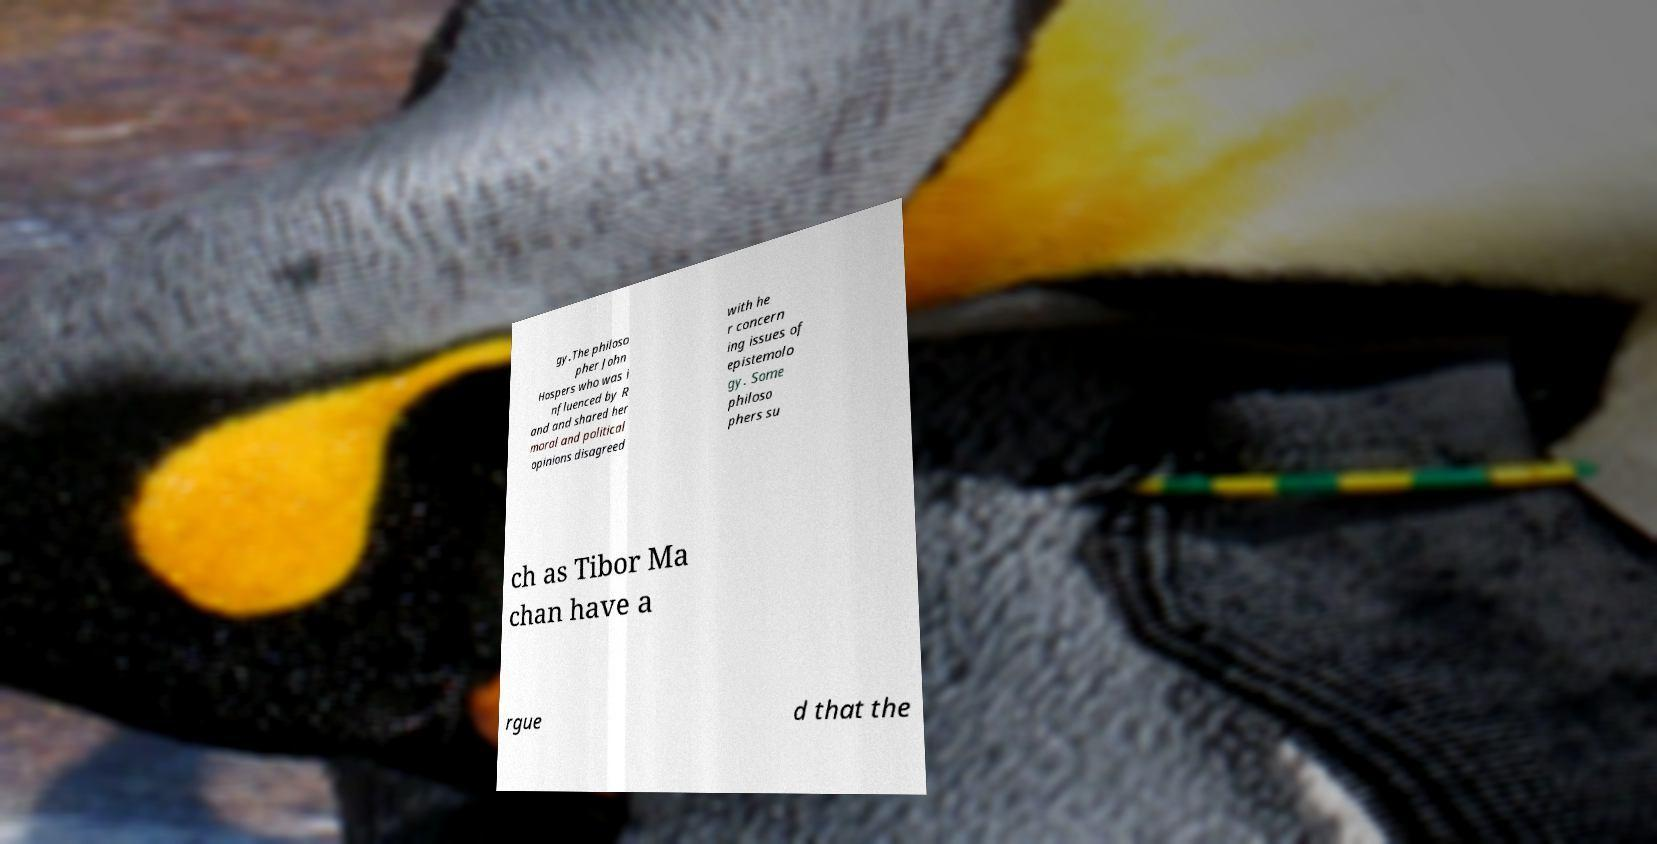What messages or text are displayed in this image? I need them in a readable, typed format. gy.The philoso pher John Hospers who was i nfluenced by R and and shared her moral and political opinions disagreed with he r concern ing issues of epistemolo gy. Some philoso phers su ch as Tibor Ma chan have a rgue d that the 